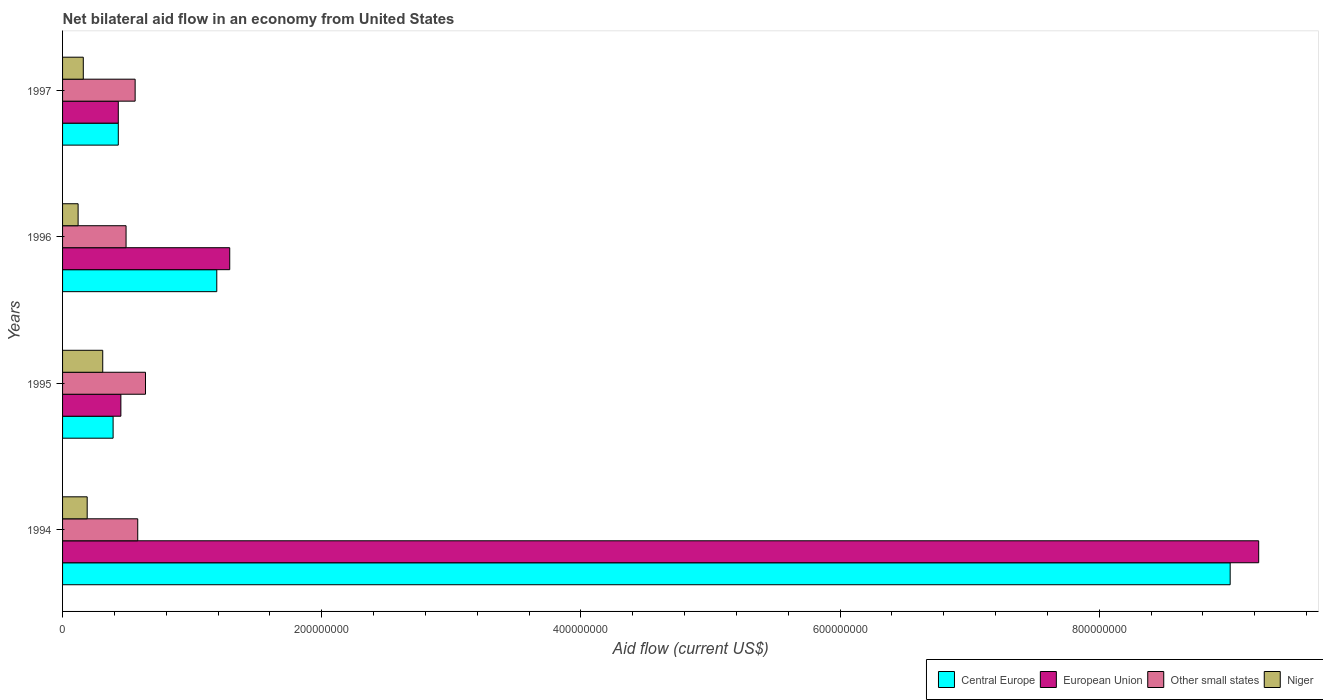How many different coloured bars are there?
Provide a short and direct response. 4. How many bars are there on the 1st tick from the top?
Provide a succinct answer. 4. How many bars are there on the 2nd tick from the bottom?
Your answer should be very brief. 4. What is the net bilateral aid flow in European Union in 1997?
Ensure brevity in your answer.  4.30e+07. Across all years, what is the maximum net bilateral aid flow in Niger?
Provide a succinct answer. 3.10e+07. Across all years, what is the minimum net bilateral aid flow in Central Europe?
Provide a succinct answer. 3.90e+07. In which year was the net bilateral aid flow in Central Europe minimum?
Make the answer very short. 1995. What is the total net bilateral aid flow in Niger in the graph?
Your answer should be very brief. 7.80e+07. What is the difference between the net bilateral aid flow in Niger in 1994 and that in 1995?
Keep it short and to the point. -1.20e+07. What is the difference between the net bilateral aid flow in Niger in 1996 and the net bilateral aid flow in Other small states in 1997?
Offer a terse response. -4.40e+07. What is the average net bilateral aid flow in Central Europe per year?
Your response must be concise. 2.76e+08. In the year 1997, what is the difference between the net bilateral aid flow in European Union and net bilateral aid flow in Other small states?
Offer a very short reply. -1.30e+07. Is the net bilateral aid flow in Other small states in 1995 less than that in 1997?
Provide a short and direct response. No. What is the difference between the highest and the second highest net bilateral aid flow in Other small states?
Make the answer very short. 6.00e+06. What is the difference between the highest and the lowest net bilateral aid flow in Other small states?
Your answer should be very brief. 1.50e+07. In how many years, is the net bilateral aid flow in Niger greater than the average net bilateral aid flow in Niger taken over all years?
Your answer should be very brief. 1. Is the sum of the net bilateral aid flow in Niger in 1994 and 1996 greater than the maximum net bilateral aid flow in Central Europe across all years?
Give a very brief answer. No. What does the 4th bar from the top in 1994 represents?
Provide a short and direct response. Central Europe. What does the 3rd bar from the bottom in 1997 represents?
Offer a terse response. Other small states. Is it the case that in every year, the sum of the net bilateral aid flow in Other small states and net bilateral aid flow in European Union is greater than the net bilateral aid flow in Niger?
Your answer should be very brief. Yes. What is the difference between two consecutive major ticks on the X-axis?
Provide a succinct answer. 2.00e+08. Does the graph contain grids?
Your response must be concise. No. How many legend labels are there?
Offer a terse response. 4. How are the legend labels stacked?
Give a very brief answer. Horizontal. What is the title of the graph?
Ensure brevity in your answer.  Net bilateral aid flow in an economy from United States. Does "French Polynesia" appear as one of the legend labels in the graph?
Give a very brief answer. No. What is the Aid flow (current US$) of Central Europe in 1994?
Make the answer very short. 9.01e+08. What is the Aid flow (current US$) of European Union in 1994?
Keep it short and to the point. 9.23e+08. What is the Aid flow (current US$) of Other small states in 1994?
Your response must be concise. 5.80e+07. What is the Aid flow (current US$) in Niger in 1994?
Your answer should be very brief. 1.90e+07. What is the Aid flow (current US$) of Central Europe in 1995?
Offer a terse response. 3.90e+07. What is the Aid flow (current US$) in European Union in 1995?
Make the answer very short. 4.50e+07. What is the Aid flow (current US$) in Other small states in 1995?
Give a very brief answer. 6.40e+07. What is the Aid flow (current US$) of Niger in 1995?
Provide a succinct answer. 3.10e+07. What is the Aid flow (current US$) in Central Europe in 1996?
Provide a short and direct response. 1.19e+08. What is the Aid flow (current US$) in European Union in 1996?
Provide a succinct answer. 1.29e+08. What is the Aid flow (current US$) of Other small states in 1996?
Offer a very short reply. 4.90e+07. What is the Aid flow (current US$) of Niger in 1996?
Your answer should be very brief. 1.20e+07. What is the Aid flow (current US$) of Central Europe in 1997?
Your response must be concise. 4.30e+07. What is the Aid flow (current US$) of European Union in 1997?
Give a very brief answer. 4.30e+07. What is the Aid flow (current US$) in Other small states in 1997?
Your answer should be compact. 5.60e+07. What is the Aid flow (current US$) in Niger in 1997?
Offer a terse response. 1.60e+07. Across all years, what is the maximum Aid flow (current US$) of Central Europe?
Keep it short and to the point. 9.01e+08. Across all years, what is the maximum Aid flow (current US$) of European Union?
Your response must be concise. 9.23e+08. Across all years, what is the maximum Aid flow (current US$) in Other small states?
Offer a very short reply. 6.40e+07. Across all years, what is the maximum Aid flow (current US$) in Niger?
Your response must be concise. 3.10e+07. Across all years, what is the minimum Aid flow (current US$) in Central Europe?
Give a very brief answer. 3.90e+07. Across all years, what is the minimum Aid flow (current US$) of European Union?
Make the answer very short. 4.30e+07. Across all years, what is the minimum Aid flow (current US$) in Other small states?
Provide a succinct answer. 4.90e+07. What is the total Aid flow (current US$) in Central Europe in the graph?
Your response must be concise. 1.10e+09. What is the total Aid flow (current US$) in European Union in the graph?
Your response must be concise. 1.14e+09. What is the total Aid flow (current US$) of Other small states in the graph?
Provide a succinct answer. 2.27e+08. What is the total Aid flow (current US$) of Niger in the graph?
Keep it short and to the point. 7.80e+07. What is the difference between the Aid flow (current US$) of Central Europe in 1994 and that in 1995?
Ensure brevity in your answer.  8.62e+08. What is the difference between the Aid flow (current US$) of European Union in 1994 and that in 1995?
Your answer should be very brief. 8.78e+08. What is the difference between the Aid flow (current US$) in Other small states in 1994 and that in 1995?
Your answer should be very brief. -6.00e+06. What is the difference between the Aid flow (current US$) of Niger in 1994 and that in 1995?
Offer a terse response. -1.20e+07. What is the difference between the Aid flow (current US$) of Central Europe in 1994 and that in 1996?
Your answer should be very brief. 7.82e+08. What is the difference between the Aid flow (current US$) of European Union in 1994 and that in 1996?
Your response must be concise. 7.94e+08. What is the difference between the Aid flow (current US$) of Other small states in 1994 and that in 1996?
Your answer should be compact. 9.00e+06. What is the difference between the Aid flow (current US$) in Central Europe in 1994 and that in 1997?
Your answer should be very brief. 8.58e+08. What is the difference between the Aid flow (current US$) in European Union in 1994 and that in 1997?
Your response must be concise. 8.80e+08. What is the difference between the Aid flow (current US$) in Central Europe in 1995 and that in 1996?
Your answer should be very brief. -8.00e+07. What is the difference between the Aid flow (current US$) of European Union in 1995 and that in 1996?
Give a very brief answer. -8.40e+07. What is the difference between the Aid flow (current US$) of Other small states in 1995 and that in 1996?
Provide a succinct answer. 1.50e+07. What is the difference between the Aid flow (current US$) in Niger in 1995 and that in 1996?
Provide a short and direct response. 1.90e+07. What is the difference between the Aid flow (current US$) in European Union in 1995 and that in 1997?
Offer a very short reply. 2.00e+06. What is the difference between the Aid flow (current US$) of Other small states in 1995 and that in 1997?
Your answer should be very brief. 8.00e+06. What is the difference between the Aid flow (current US$) of Niger in 1995 and that in 1997?
Make the answer very short. 1.50e+07. What is the difference between the Aid flow (current US$) of Central Europe in 1996 and that in 1997?
Your response must be concise. 7.60e+07. What is the difference between the Aid flow (current US$) of European Union in 1996 and that in 1997?
Ensure brevity in your answer.  8.60e+07. What is the difference between the Aid flow (current US$) in Other small states in 1996 and that in 1997?
Your response must be concise. -7.00e+06. What is the difference between the Aid flow (current US$) in Niger in 1996 and that in 1997?
Keep it short and to the point. -4.00e+06. What is the difference between the Aid flow (current US$) of Central Europe in 1994 and the Aid flow (current US$) of European Union in 1995?
Provide a short and direct response. 8.56e+08. What is the difference between the Aid flow (current US$) of Central Europe in 1994 and the Aid flow (current US$) of Other small states in 1995?
Your answer should be very brief. 8.37e+08. What is the difference between the Aid flow (current US$) in Central Europe in 1994 and the Aid flow (current US$) in Niger in 1995?
Your answer should be compact. 8.70e+08. What is the difference between the Aid flow (current US$) in European Union in 1994 and the Aid flow (current US$) in Other small states in 1995?
Your response must be concise. 8.59e+08. What is the difference between the Aid flow (current US$) in European Union in 1994 and the Aid flow (current US$) in Niger in 1995?
Provide a succinct answer. 8.92e+08. What is the difference between the Aid flow (current US$) in Other small states in 1994 and the Aid flow (current US$) in Niger in 1995?
Make the answer very short. 2.70e+07. What is the difference between the Aid flow (current US$) of Central Europe in 1994 and the Aid flow (current US$) of European Union in 1996?
Offer a terse response. 7.72e+08. What is the difference between the Aid flow (current US$) of Central Europe in 1994 and the Aid flow (current US$) of Other small states in 1996?
Make the answer very short. 8.52e+08. What is the difference between the Aid flow (current US$) in Central Europe in 1994 and the Aid flow (current US$) in Niger in 1996?
Offer a very short reply. 8.89e+08. What is the difference between the Aid flow (current US$) in European Union in 1994 and the Aid flow (current US$) in Other small states in 1996?
Ensure brevity in your answer.  8.74e+08. What is the difference between the Aid flow (current US$) of European Union in 1994 and the Aid flow (current US$) of Niger in 1996?
Provide a short and direct response. 9.11e+08. What is the difference between the Aid flow (current US$) of Other small states in 1994 and the Aid flow (current US$) of Niger in 1996?
Keep it short and to the point. 4.60e+07. What is the difference between the Aid flow (current US$) in Central Europe in 1994 and the Aid flow (current US$) in European Union in 1997?
Provide a succinct answer. 8.58e+08. What is the difference between the Aid flow (current US$) in Central Europe in 1994 and the Aid flow (current US$) in Other small states in 1997?
Offer a terse response. 8.45e+08. What is the difference between the Aid flow (current US$) of Central Europe in 1994 and the Aid flow (current US$) of Niger in 1997?
Make the answer very short. 8.85e+08. What is the difference between the Aid flow (current US$) of European Union in 1994 and the Aid flow (current US$) of Other small states in 1997?
Your response must be concise. 8.67e+08. What is the difference between the Aid flow (current US$) in European Union in 1994 and the Aid flow (current US$) in Niger in 1997?
Keep it short and to the point. 9.07e+08. What is the difference between the Aid flow (current US$) in Other small states in 1994 and the Aid flow (current US$) in Niger in 1997?
Provide a succinct answer. 4.20e+07. What is the difference between the Aid flow (current US$) of Central Europe in 1995 and the Aid flow (current US$) of European Union in 1996?
Make the answer very short. -9.00e+07. What is the difference between the Aid flow (current US$) in Central Europe in 1995 and the Aid flow (current US$) in Other small states in 1996?
Your answer should be very brief. -1.00e+07. What is the difference between the Aid flow (current US$) in Central Europe in 1995 and the Aid flow (current US$) in Niger in 1996?
Your response must be concise. 2.70e+07. What is the difference between the Aid flow (current US$) of European Union in 1995 and the Aid flow (current US$) of Other small states in 1996?
Provide a succinct answer. -4.00e+06. What is the difference between the Aid flow (current US$) of European Union in 1995 and the Aid flow (current US$) of Niger in 1996?
Offer a very short reply. 3.30e+07. What is the difference between the Aid flow (current US$) of Other small states in 1995 and the Aid flow (current US$) of Niger in 1996?
Keep it short and to the point. 5.20e+07. What is the difference between the Aid flow (current US$) in Central Europe in 1995 and the Aid flow (current US$) in Other small states in 1997?
Keep it short and to the point. -1.70e+07. What is the difference between the Aid flow (current US$) in Central Europe in 1995 and the Aid flow (current US$) in Niger in 1997?
Keep it short and to the point. 2.30e+07. What is the difference between the Aid flow (current US$) in European Union in 1995 and the Aid flow (current US$) in Other small states in 1997?
Ensure brevity in your answer.  -1.10e+07. What is the difference between the Aid flow (current US$) in European Union in 1995 and the Aid flow (current US$) in Niger in 1997?
Your answer should be compact. 2.90e+07. What is the difference between the Aid flow (current US$) in Other small states in 1995 and the Aid flow (current US$) in Niger in 1997?
Ensure brevity in your answer.  4.80e+07. What is the difference between the Aid flow (current US$) of Central Europe in 1996 and the Aid flow (current US$) of European Union in 1997?
Give a very brief answer. 7.60e+07. What is the difference between the Aid flow (current US$) in Central Europe in 1996 and the Aid flow (current US$) in Other small states in 1997?
Your response must be concise. 6.30e+07. What is the difference between the Aid flow (current US$) in Central Europe in 1996 and the Aid flow (current US$) in Niger in 1997?
Give a very brief answer. 1.03e+08. What is the difference between the Aid flow (current US$) in European Union in 1996 and the Aid flow (current US$) in Other small states in 1997?
Provide a short and direct response. 7.30e+07. What is the difference between the Aid flow (current US$) in European Union in 1996 and the Aid flow (current US$) in Niger in 1997?
Make the answer very short. 1.13e+08. What is the difference between the Aid flow (current US$) in Other small states in 1996 and the Aid flow (current US$) in Niger in 1997?
Your response must be concise. 3.30e+07. What is the average Aid flow (current US$) of Central Europe per year?
Your response must be concise. 2.76e+08. What is the average Aid flow (current US$) of European Union per year?
Offer a very short reply. 2.85e+08. What is the average Aid flow (current US$) in Other small states per year?
Ensure brevity in your answer.  5.68e+07. What is the average Aid flow (current US$) of Niger per year?
Keep it short and to the point. 1.95e+07. In the year 1994, what is the difference between the Aid flow (current US$) of Central Europe and Aid flow (current US$) of European Union?
Your answer should be very brief. -2.20e+07. In the year 1994, what is the difference between the Aid flow (current US$) in Central Europe and Aid flow (current US$) in Other small states?
Your response must be concise. 8.43e+08. In the year 1994, what is the difference between the Aid flow (current US$) in Central Europe and Aid flow (current US$) in Niger?
Give a very brief answer. 8.82e+08. In the year 1994, what is the difference between the Aid flow (current US$) of European Union and Aid flow (current US$) of Other small states?
Offer a terse response. 8.65e+08. In the year 1994, what is the difference between the Aid flow (current US$) of European Union and Aid flow (current US$) of Niger?
Offer a terse response. 9.04e+08. In the year 1994, what is the difference between the Aid flow (current US$) of Other small states and Aid flow (current US$) of Niger?
Keep it short and to the point. 3.90e+07. In the year 1995, what is the difference between the Aid flow (current US$) of Central Europe and Aid flow (current US$) of European Union?
Make the answer very short. -6.00e+06. In the year 1995, what is the difference between the Aid flow (current US$) of Central Europe and Aid flow (current US$) of Other small states?
Give a very brief answer. -2.50e+07. In the year 1995, what is the difference between the Aid flow (current US$) in European Union and Aid flow (current US$) in Other small states?
Provide a short and direct response. -1.90e+07. In the year 1995, what is the difference between the Aid flow (current US$) in European Union and Aid flow (current US$) in Niger?
Your answer should be compact. 1.40e+07. In the year 1995, what is the difference between the Aid flow (current US$) in Other small states and Aid flow (current US$) in Niger?
Offer a terse response. 3.30e+07. In the year 1996, what is the difference between the Aid flow (current US$) in Central Europe and Aid flow (current US$) in European Union?
Your answer should be very brief. -1.00e+07. In the year 1996, what is the difference between the Aid flow (current US$) of Central Europe and Aid flow (current US$) of Other small states?
Offer a terse response. 7.00e+07. In the year 1996, what is the difference between the Aid flow (current US$) in Central Europe and Aid flow (current US$) in Niger?
Provide a succinct answer. 1.07e+08. In the year 1996, what is the difference between the Aid flow (current US$) in European Union and Aid flow (current US$) in Other small states?
Offer a terse response. 8.00e+07. In the year 1996, what is the difference between the Aid flow (current US$) in European Union and Aid flow (current US$) in Niger?
Make the answer very short. 1.17e+08. In the year 1996, what is the difference between the Aid flow (current US$) of Other small states and Aid flow (current US$) of Niger?
Offer a very short reply. 3.70e+07. In the year 1997, what is the difference between the Aid flow (current US$) of Central Europe and Aid flow (current US$) of European Union?
Keep it short and to the point. 0. In the year 1997, what is the difference between the Aid flow (current US$) of Central Europe and Aid flow (current US$) of Other small states?
Make the answer very short. -1.30e+07. In the year 1997, what is the difference between the Aid flow (current US$) in Central Europe and Aid flow (current US$) in Niger?
Provide a succinct answer. 2.70e+07. In the year 1997, what is the difference between the Aid flow (current US$) in European Union and Aid flow (current US$) in Other small states?
Keep it short and to the point. -1.30e+07. In the year 1997, what is the difference between the Aid flow (current US$) of European Union and Aid flow (current US$) of Niger?
Ensure brevity in your answer.  2.70e+07. In the year 1997, what is the difference between the Aid flow (current US$) in Other small states and Aid flow (current US$) in Niger?
Make the answer very short. 4.00e+07. What is the ratio of the Aid flow (current US$) in Central Europe in 1994 to that in 1995?
Provide a succinct answer. 23.1. What is the ratio of the Aid flow (current US$) in European Union in 1994 to that in 1995?
Ensure brevity in your answer.  20.51. What is the ratio of the Aid flow (current US$) of Other small states in 1994 to that in 1995?
Provide a succinct answer. 0.91. What is the ratio of the Aid flow (current US$) in Niger in 1994 to that in 1995?
Your answer should be very brief. 0.61. What is the ratio of the Aid flow (current US$) in Central Europe in 1994 to that in 1996?
Provide a succinct answer. 7.57. What is the ratio of the Aid flow (current US$) in European Union in 1994 to that in 1996?
Offer a very short reply. 7.16. What is the ratio of the Aid flow (current US$) of Other small states in 1994 to that in 1996?
Keep it short and to the point. 1.18. What is the ratio of the Aid flow (current US$) in Niger in 1994 to that in 1996?
Provide a short and direct response. 1.58. What is the ratio of the Aid flow (current US$) of Central Europe in 1994 to that in 1997?
Provide a succinct answer. 20.95. What is the ratio of the Aid flow (current US$) of European Union in 1994 to that in 1997?
Your answer should be compact. 21.47. What is the ratio of the Aid flow (current US$) in Other small states in 1994 to that in 1997?
Make the answer very short. 1.04. What is the ratio of the Aid flow (current US$) in Niger in 1994 to that in 1997?
Offer a terse response. 1.19. What is the ratio of the Aid flow (current US$) in Central Europe in 1995 to that in 1996?
Provide a short and direct response. 0.33. What is the ratio of the Aid flow (current US$) in European Union in 1995 to that in 1996?
Make the answer very short. 0.35. What is the ratio of the Aid flow (current US$) in Other small states in 1995 to that in 1996?
Offer a very short reply. 1.31. What is the ratio of the Aid flow (current US$) of Niger in 1995 to that in 1996?
Ensure brevity in your answer.  2.58. What is the ratio of the Aid flow (current US$) of Central Europe in 1995 to that in 1997?
Your response must be concise. 0.91. What is the ratio of the Aid flow (current US$) in European Union in 1995 to that in 1997?
Offer a very short reply. 1.05. What is the ratio of the Aid flow (current US$) of Niger in 1995 to that in 1997?
Offer a very short reply. 1.94. What is the ratio of the Aid flow (current US$) of Central Europe in 1996 to that in 1997?
Give a very brief answer. 2.77. What is the difference between the highest and the second highest Aid flow (current US$) of Central Europe?
Your response must be concise. 7.82e+08. What is the difference between the highest and the second highest Aid flow (current US$) in European Union?
Make the answer very short. 7.94e+08. What is the difference between the highest and the second highest Aid flow (current US$) of Niger?
Your answer should be very brief. 1.20e+07. What is the difference between the highest and the lowest Aid flow (current US$) in Central Europe?
Ensure brevity in your answer.  8.62e+08. What is the difference between the highest and the lowest Aid flow (current US$) in European Union?
Give a very brief answer. 8.80e+08. What is the difference between the highest and the lowest Aid flow (current US$) in Other small states?
Your answer should be very brief. 1.50e+07. What is the difference between the highest and the lowest Aid flow (current US$) of Niger?
Your answer should be compact. 1.90e+07. 